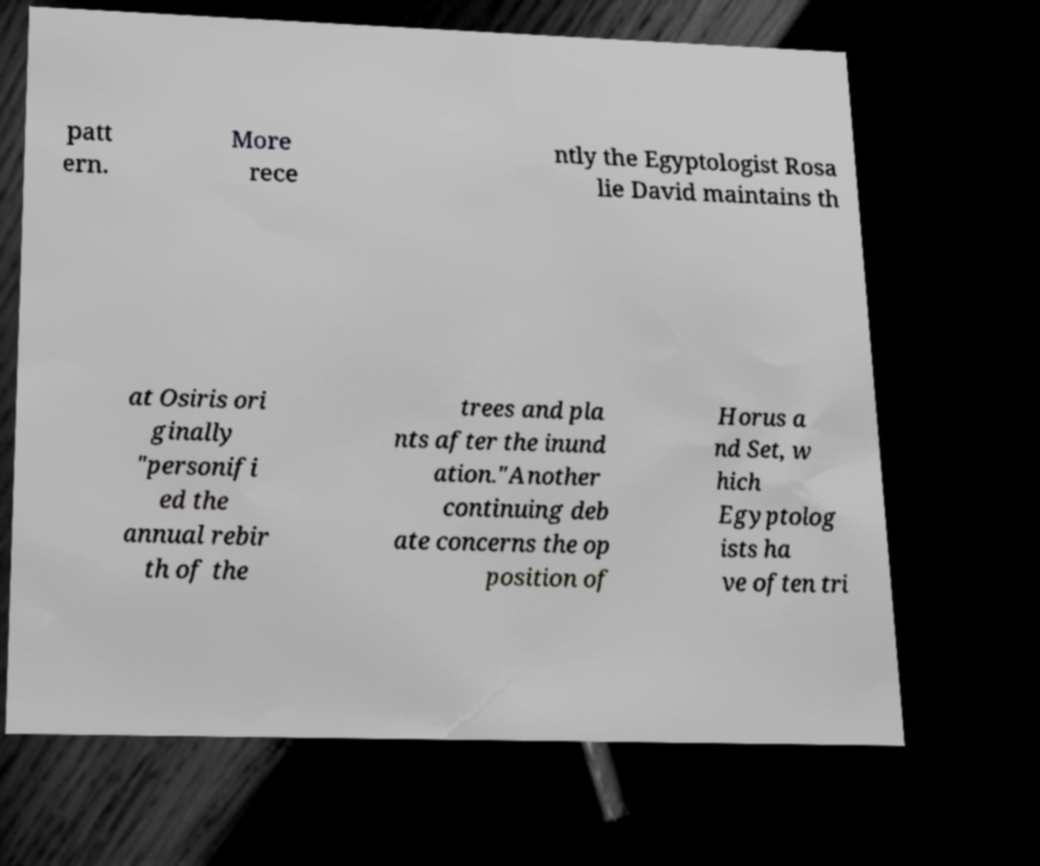I need the written content from this picture converted into text. Can you do that? patt ern. More rece ntly the Egyptologist Rosa lie David maintains th at Osiris ori ginally "personifi ed the annual rebir th of the trees and pla nts after the inund ation."Another continuing deb ate concerns the op position of Horus a nd Set, w hich Egyptolog ists ha ve often tri 